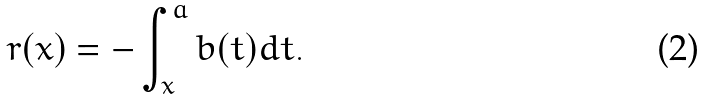<formula> <loc_0><loc_0><loc_500><loc_500>r ( x ) = - \int _ { x } ^ { a } b ( t ) d t .</formula> 